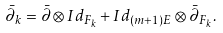<formula> <loc_0><loc_0><loc_500><loc_500>\bar { \partial } _ { k } = \bar { \partial } \otimes I d _ { F _ { k } } + I d _ { ( m + 1 ) E } \otimes \bar { \partial } _ { F _ { k } } .</formula> 